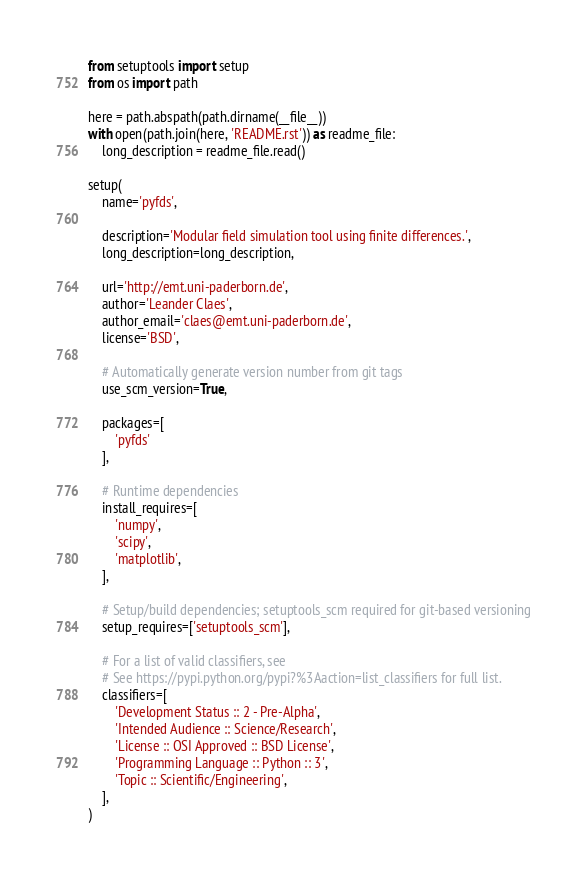<code> <loc_0><loc_0><loc_500><loc_500><_Python_>from setuptools import setup
from os import path

here = path.abspath(path.dirname(__file__))
with open(path.join(here, 'README.rst')) as readme_file:
    long_description = readme_file.read()

setup(
    name='pyfds',

    description='Modular field simulation tool using finite differences.',
    long_description=long_description,

    url='http://emt.uni-paderborn.de',
    author='Leander Claes',
    author_email='claes@emt.uni-paderborn.de',
    license='BSD',

    # Automatically generate version number from git tags
    use_scm_version=True,

    packages=[
        'pyfds'
    ],

    # Runtime dependencies
    install_requires=[
        'numpy',
        'scipy',
        'matplotlib',
    ],

    # Setup/build dependencies; setuptools_scm required for git-based versioning
    setup_requires=['setuptools_scm'],

    # For a list of valid classifiers, see
    # See https://pypi.python.org/pypi?%3Aaction=list_classifiers for full list.
    classifiers=[
        'Development Status :: 2 - Pre-Alpha',
        'Intended Audience :: Science/Research',
        'License :: OSI Approved :: BSD License',
        'Programming Language :: Python :: 3',
        'Topic :: Scientific/Engineering',
    ],
)
</code> 